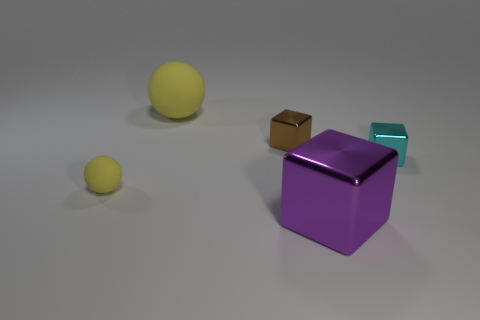What number of other objects are the same color as the big shiny thing?
Your response must be concise. 0. How many other objects are the same size as the purple thing?
Your answer should be compact. 1. Are there any purple spheres of the same size as the brown metal block?
Keep it short and to the point. No. There is a matte ball in front of the brown metal cube; is it the same color as the big rubber ball?
Provide a succinct answer. Yes. What number of objects are either small gray rubber spheres or large purple things?
Offer a very short reply. 1. There is a rubber thing that is in front of the brown object; is its size the same as the large yellow matte object?
Offer a terse response. No. What is the size of the metallic cube that is to the right of the small brown metallic cube and behind the purple metal block?
Your answer should be very brief. Small. What number of other objects are the same shape as the purple metal object?
Your answer should be compact. 2. What number of other objects are the same material as the tiny brown cube?
Make the answer very short. 2. There is another yellow rubber thing that is the same shape as the small yellow thing; what size is it?
Make the answer very short. Large. 